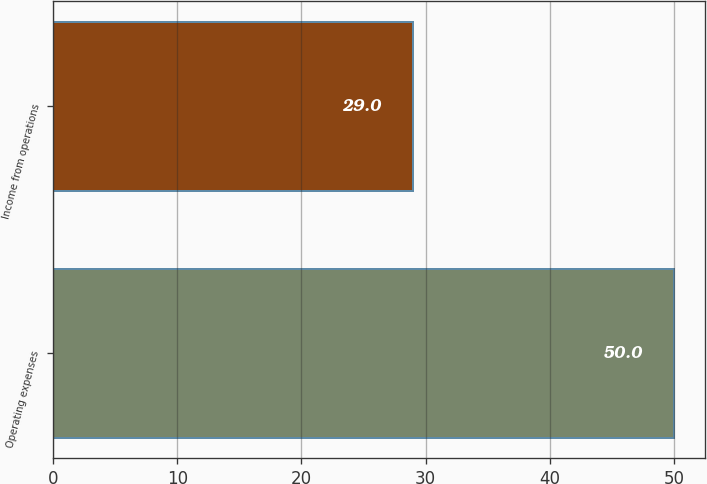Convert chart to OTSL. <chart><loc_0><loc_0><loc_500><loc_500><bar_chart><fcel>Operating expenses<fcel>Income from operations<nl><fcel>50<fcel>29<nl></chart> 